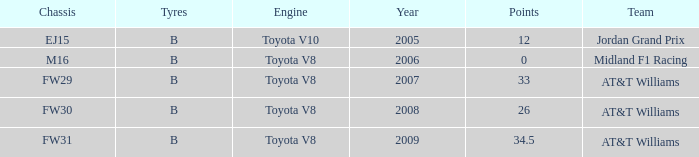What is the earliest year that had under 26 points and a toyota v8 engine? 2006.0. 